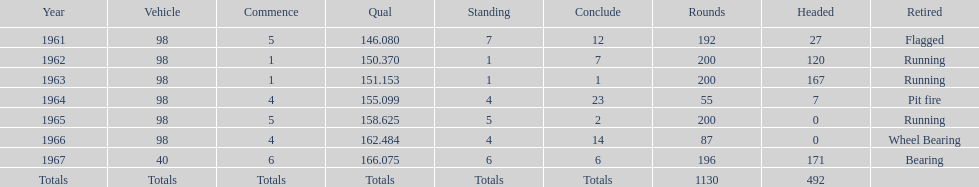How many times did he finish in the top three? 2. 